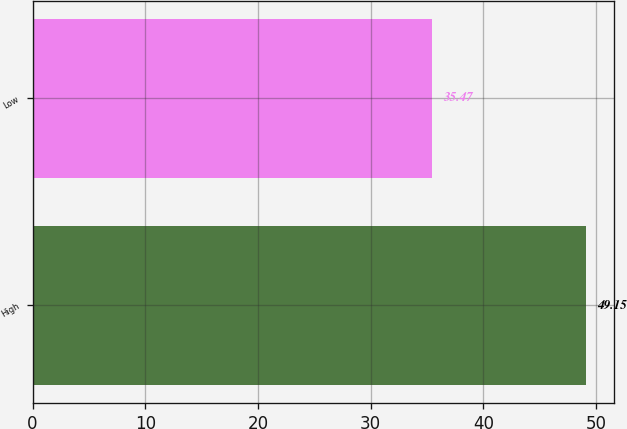<chart> <loc_0><loc_0><loc_500><loc_500><bar_chart><fcel>High<fcel>Low<nl><fcel>49.15<fcel>35.47<nl></chart> 